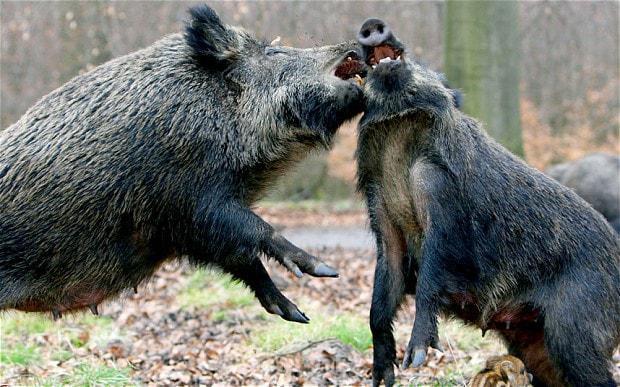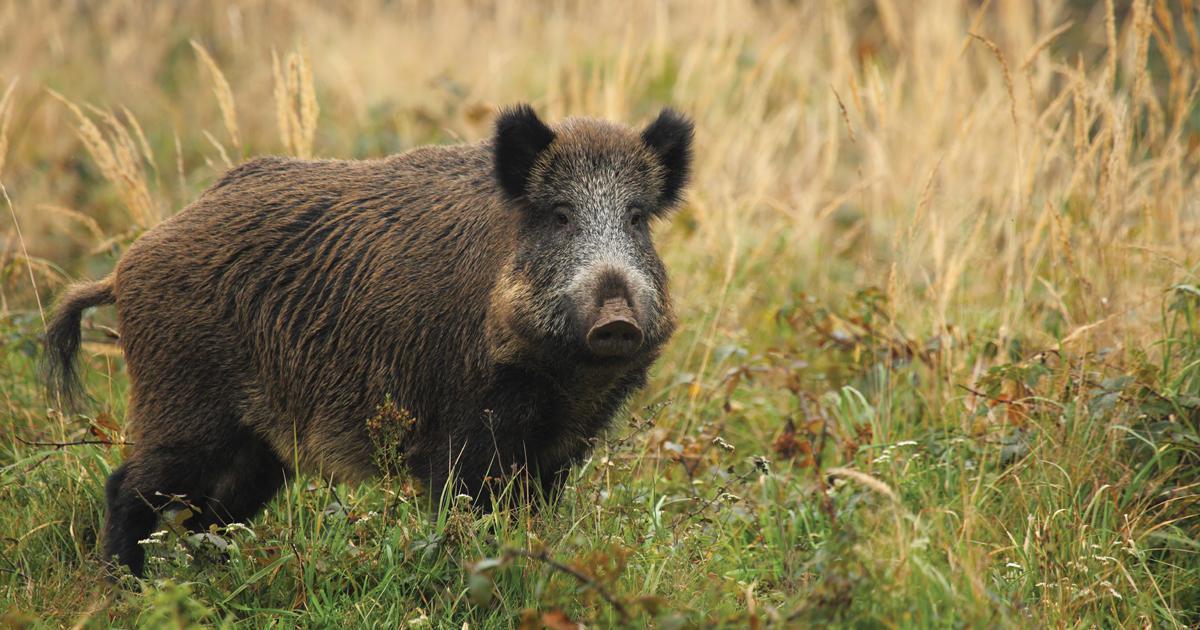The first image is the image on the left, the second image is the image on the right. Examine the images to the left and right. Is the description "There are at least two animals in the image on the left." accurate? Answer yes or no. Yes. 